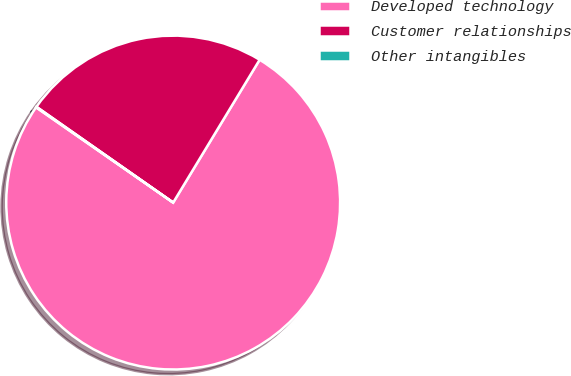<chart> <loc_0><loc_0><loc_500><loc_500><pie_chart><fcel>Developed technology<fcel>Customer relationships<fcel>Other intangibles<nl><fcel>75.99%<fcel>23.94%<fcel>0.06%<nl></chart> 